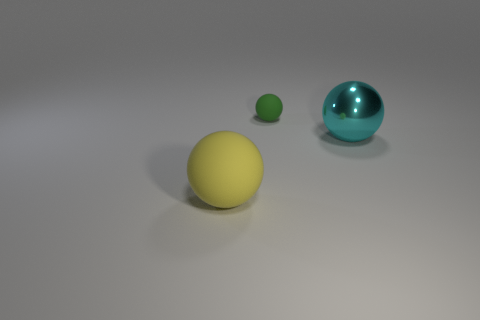Do the sphere that is in front of the metal ball and the small matte sphere have the same color?
Make the answer very short. No. What number of objects are either rubber objects that are behind the cyan sphere or large metallic spheres?
Keep it short and to the point. 2. What material is the big ball that is behind the matte ball left of the tiny green matte ball that is to the left of the cyan object made of?
Ensure brevity in your answer.  Metal. Are there more small balls that are on the right side of the big metallic sphere than large yellow spheres behind the small matte sphere?
Make the answer very short. No. How many spheres are shiny objects or yellow rubber things?
Your answer should be very brief. 2. What number of green objects are in front of the rubber sphere that is behind the ball that is on the left side of the green matte ball?
Offer a terse response. 0. Are there more cyan metal cylinders than big cyan things?
Make the answer very short. No. Do the cyan sphere and the green object have the same size?
Your answer should be compact. No. What number of objects are big yellow matte objects or big cyan balls?
Give a very brief answer. 2. Are the big object on the right side of the large yellow object and the sphere that is behind the big cyan shiny sphere made of the same material?
Offer a terse response. No. 